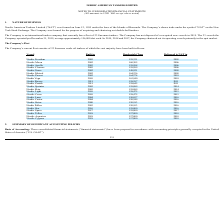From Nordic American Tankers Limited's financial document, What are the respective years that Nordic Freedom is built and delivered to NAT? The document shows two values: 2005 and 2005. From the document: "Nordic Freedom 2005 159,331 2005..." Also, What are the respective years that Nordic Moon is built and delivered to NAT? The document shows two values: 2002 and 2006. From the document: "Nordic Moon 2002 160,305 2006 Nordic Moon 2002 160,305 2006..." Also, What are the respective years that Nordic Apollo is built and delivered to NAT? The document shows two values: 2003 and 2006. From the document: "Nordic Apollo 2003 159,998 2006 Nordic Apollo 2003 159,998 2006..." Also, can you calculate: What is the average weight of the Nordic Freedom and Nordic Moon? To answer this question, I need to perform calculations using the financial data. The calculation is: (159,331 + 160,305)/2 , which equals 159818. This is based on the information: "Nordic Moon 2002 160,305 2006 Nordic Freedom 2005 159,331 2005..." The key data points involved are: 159,331, 160,305. Also, can you calculate: What is the average weight of the Nordic Apollo and Nordic Cosmos? To answer this question, I need to perform calculations using the financial data. The calculation is: (159,998 + 159,999)/2 , which equals 159998.5. This is based on the information: "Nordic Cosmos 2003 159,999 2006 Nordic Apollo 2003 159,998 2006..." The key data points involved are: 159,998, 159,999. Also, can you calculate: What is the average weight of the Nordic Grace and Nordic Mistrals? To answer this question, I need to perform calculations using the financial data. The calculation is: (149,921 + 164,236)/2 , which equals 157078.5. This is based on the information: "Nordic Mistral 2002 164,236 2009 Nordic Grace 2002 149,921 2009..." The key data points involved are: 149,921, 164,236. 